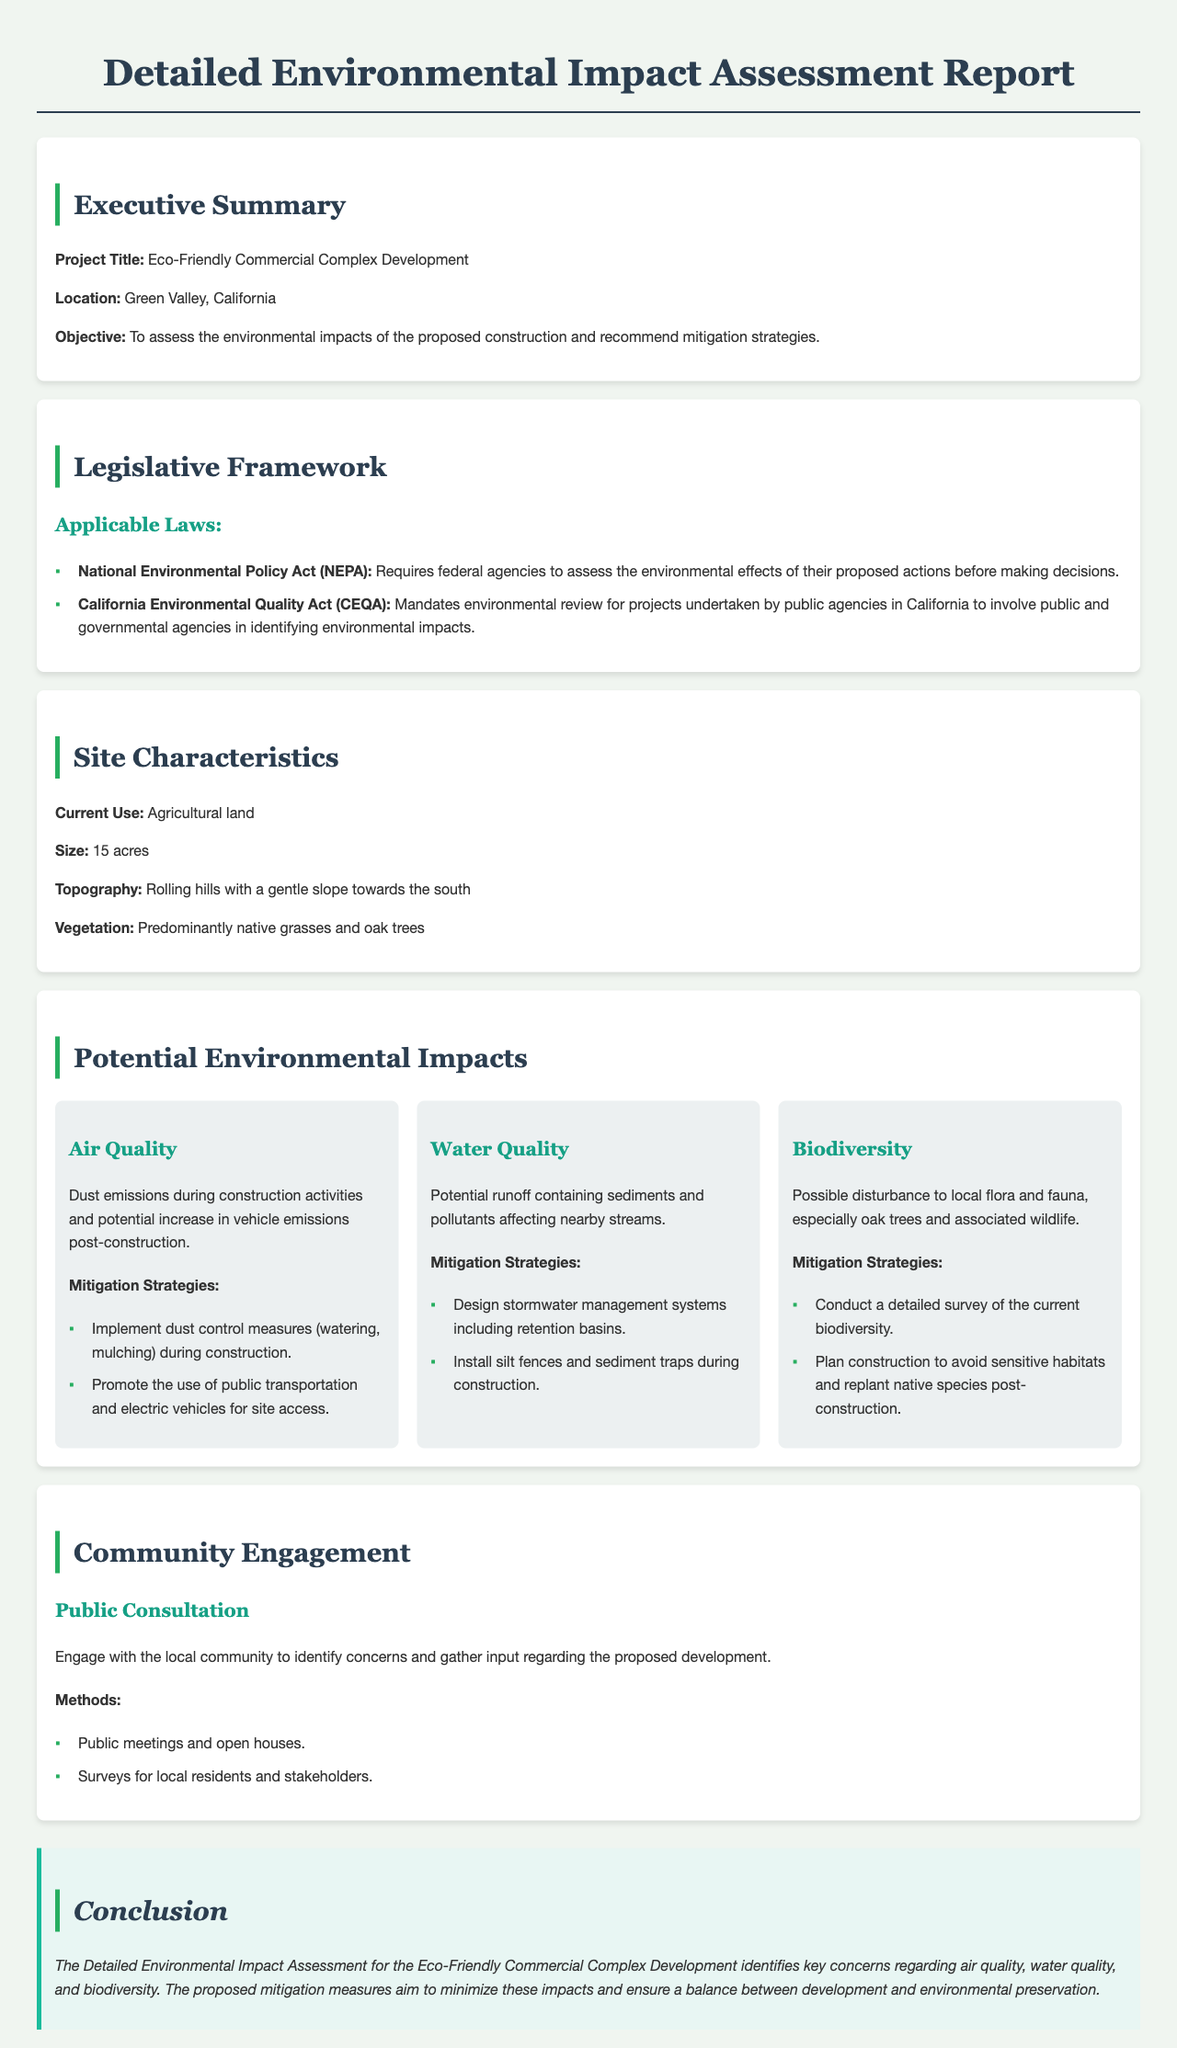What is the project title? The project title is listed in the executive summary of the report.
Answer: Eco-Friendly Commercial Complex Development What is the location of the project? The location is specified in the executive summary section of the document.
Answer: Green Valley, California How large is the proposed construction site? The size of the construction site is detailed in the site characteristics section.
Answer: 15 acres What are the two applicable laws mentioned? The legislative framework section lists the relevant laws for environmental assessment.
Answer: National Environmental Policy Act (NEPA), California Environmental Quality Act (CEQA) What is one mitigation strategy for water quality? The potential environmental impacts section provides specific mitigation strategies for water quality.
Answer: Design stormwater management systems including retention basins What community engagement method is listed? The community engagement section describes methods to involve the local community.
Answer: Public meetings and open houses What is the primary objective of the assessment? The objective is stated in the executive summary as the purpose of conducting the assessment.
Answer: To assess the environmental impacts of the proposed construction and recommend mitigation strategies What type of land is currently being used? The current use of the land is specified in the site characteristics section of the document.
Answer: Agricultural land What was identified as a potential impact on biodiversity? The biodiversity section discusses specific concerns regarding local flora and fauna.
Answer: Possible disturbance to local flora and fauna 